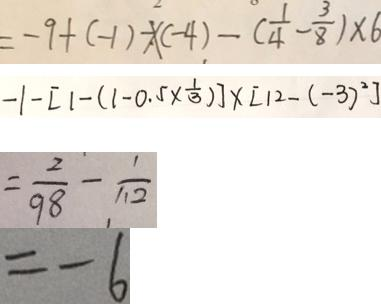<formula> <loc_0><loc_0><loc_500><loc_500>= - 9 + ( - 1 ) - \times ( - 4 ) - ( \frac { 1 } { 4 } - \frac { 3 } { 8 } ) \times 6 
 - 1 - [ 1 - ( 1 - 0 . 5 \times \frac { 1 } { 3 } ) ] \times [ 1 2 - ( - 3 ) ^ { 2 } ] 
 = \frac { 2 } { 9 8 } - \frac { 1 } { 1 1 2 } 
 = - 6</formula> 